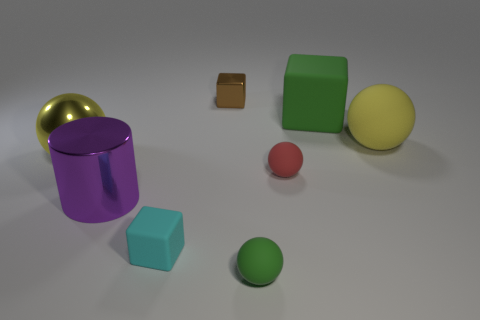Subtract all small brown metal cubes. How many cubes are left? 2 Subtract all red balls. How many balls are left? 3 Subtract 1 blocks. How many blocks are left? 2 Subtract all blue spheres. Subtract all yellow cubes. How many spheres are left? 4 Add 1 yellow matte things. How many objects exist? 9 Subtract all blocks. How many objects are left? 5 Subtract all green objects. Subtract all green matte things. How many objects are left? 4 Add 1 tiny green balls. How many tiny green balls are left? 2 Add 3 big green matte objects. How many big green matte objects exist? 4 Subtract 0 blue spheres. How many objects are left? 8 